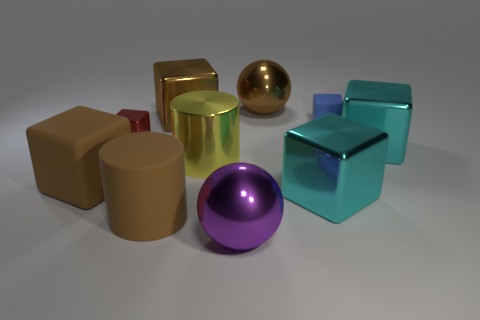How many brown blocks must be subtracted to get 1 brown blocks? 1 Subtract all brown rubber blocks. How many blocks are left? 5 Subtract all yellow cylinders. How many cylinders are left? 1 Subtract all cylinders. How many objects are left? 8 Subtract 1 spheres. How many spheres are left? 1 Subtract all red spheres. How many cyan cylinders are left? 0 Subtract all yellow metallic spheres. Subtract all balls. How many objects are left? 8 Add 5 spheres. How many spheres are left? 7 Add 1 small matte things. How many small matte things exist? 2 Subtract 2 brown cubes. How many objects are left? 8 